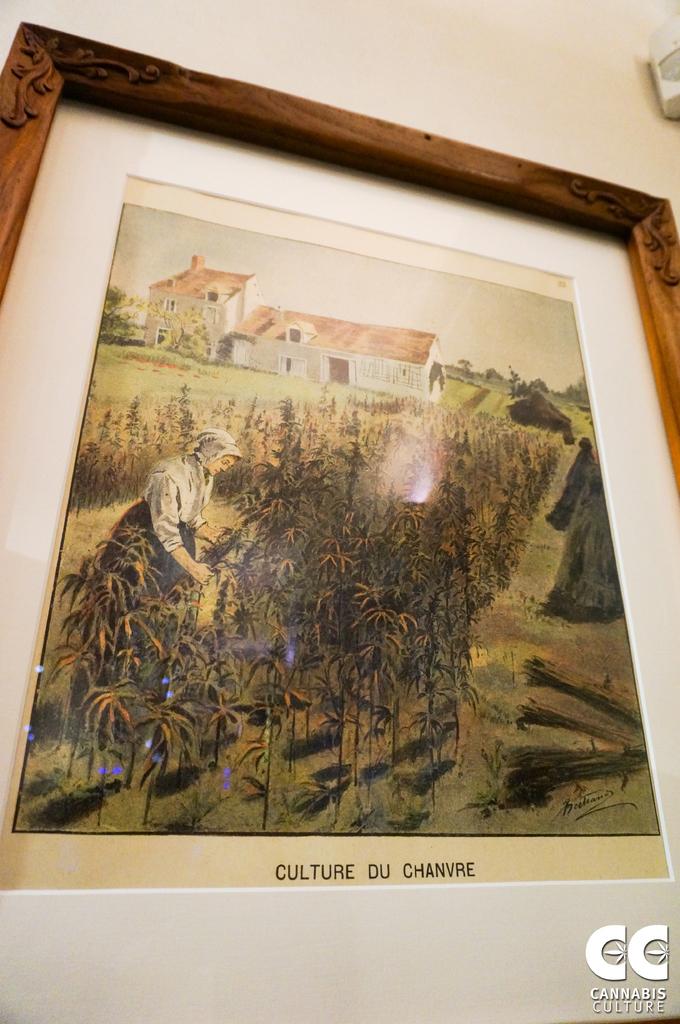What is the caption for the photo?
Provide a short and direct response. Culture du chanvre. 